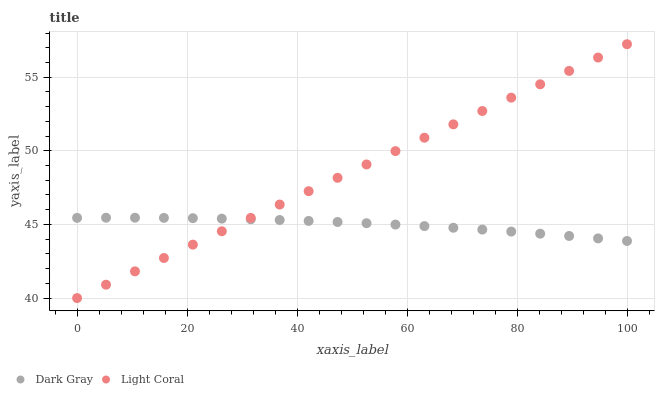Does Dark Gray have the minimum area under the curve?
Answer yes or no. Yes. Does Light Coral have the maximum area under the curve?
Answer yes or no. Yes. Does Light Coral have the minimum area under the curve?
Answer yes or no. No. Is Light Coral the smoothest?
Answer yes or no. Yes. Is Dark Gray the roughest?
Answer yes or no. Yes. Is Light Coral the roughest?
Answer yes or no. No. Does Light Coral have the lowest value?
Answer yes or no. Yes. Does Light Coral have the highest value?
Answer yes or no. Yes. Does Light Coral intersect Dark Gray?
Answer yes or no. Yes. Is Light Coral less than Dark Gray?
Answer yes or no. No. Is Light Coral greater than Dark Gray?
Answer yes or no. No. 